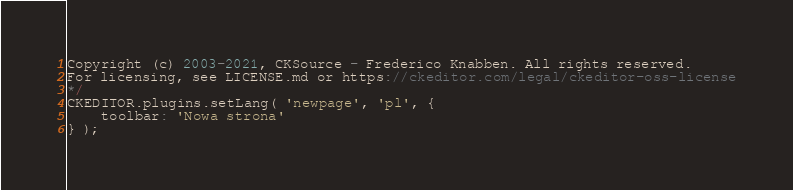<code> <loc_0><loc_0><loc_500><loc_500><_JavaScript_>Copyright (c) 2003-2021, CKSource - Frederico Knabben. All rights reserved.
For licensing, see LICENSE.md or https://ckeditor.com/legal/ckeditor-oss-license
*/
CKEDITOR.plugins.setLang( 'newpage', 'pl', {
	toolbar: 'Nowa strona'
} );
</code> 